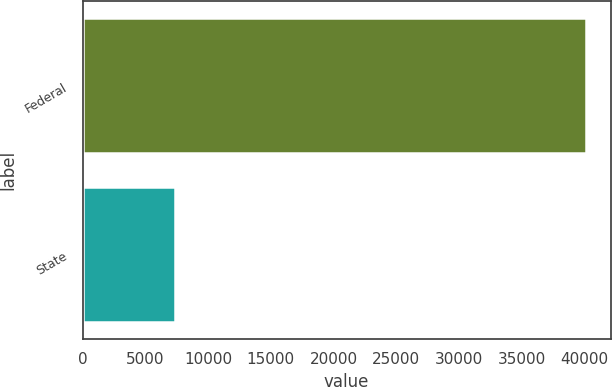Convert chart. <chart><loc_0><loc_0><loc_500><loc_500><bar_chart><fcel>Federal<fcel>State<nl><fcel>40094<fcel>7366<nl></chart> 